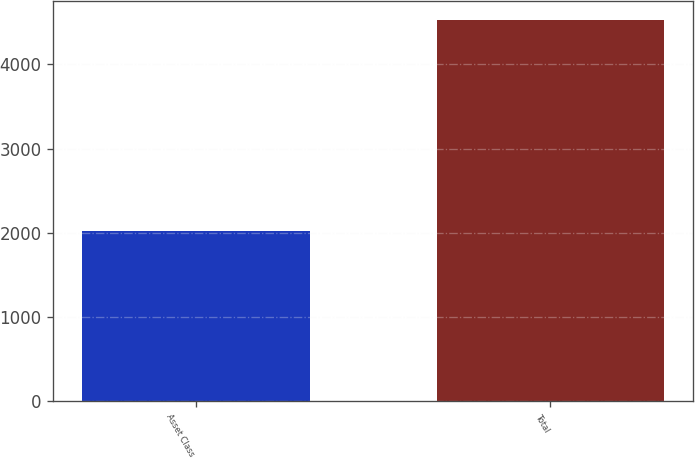Convert chart. <chart><loc_0><loc_0><loc_500><loc_500><bar_chart><fcel>Asset Class<fcel>Total<nl><fcel>2015<fcel>4532<nl></chart> 